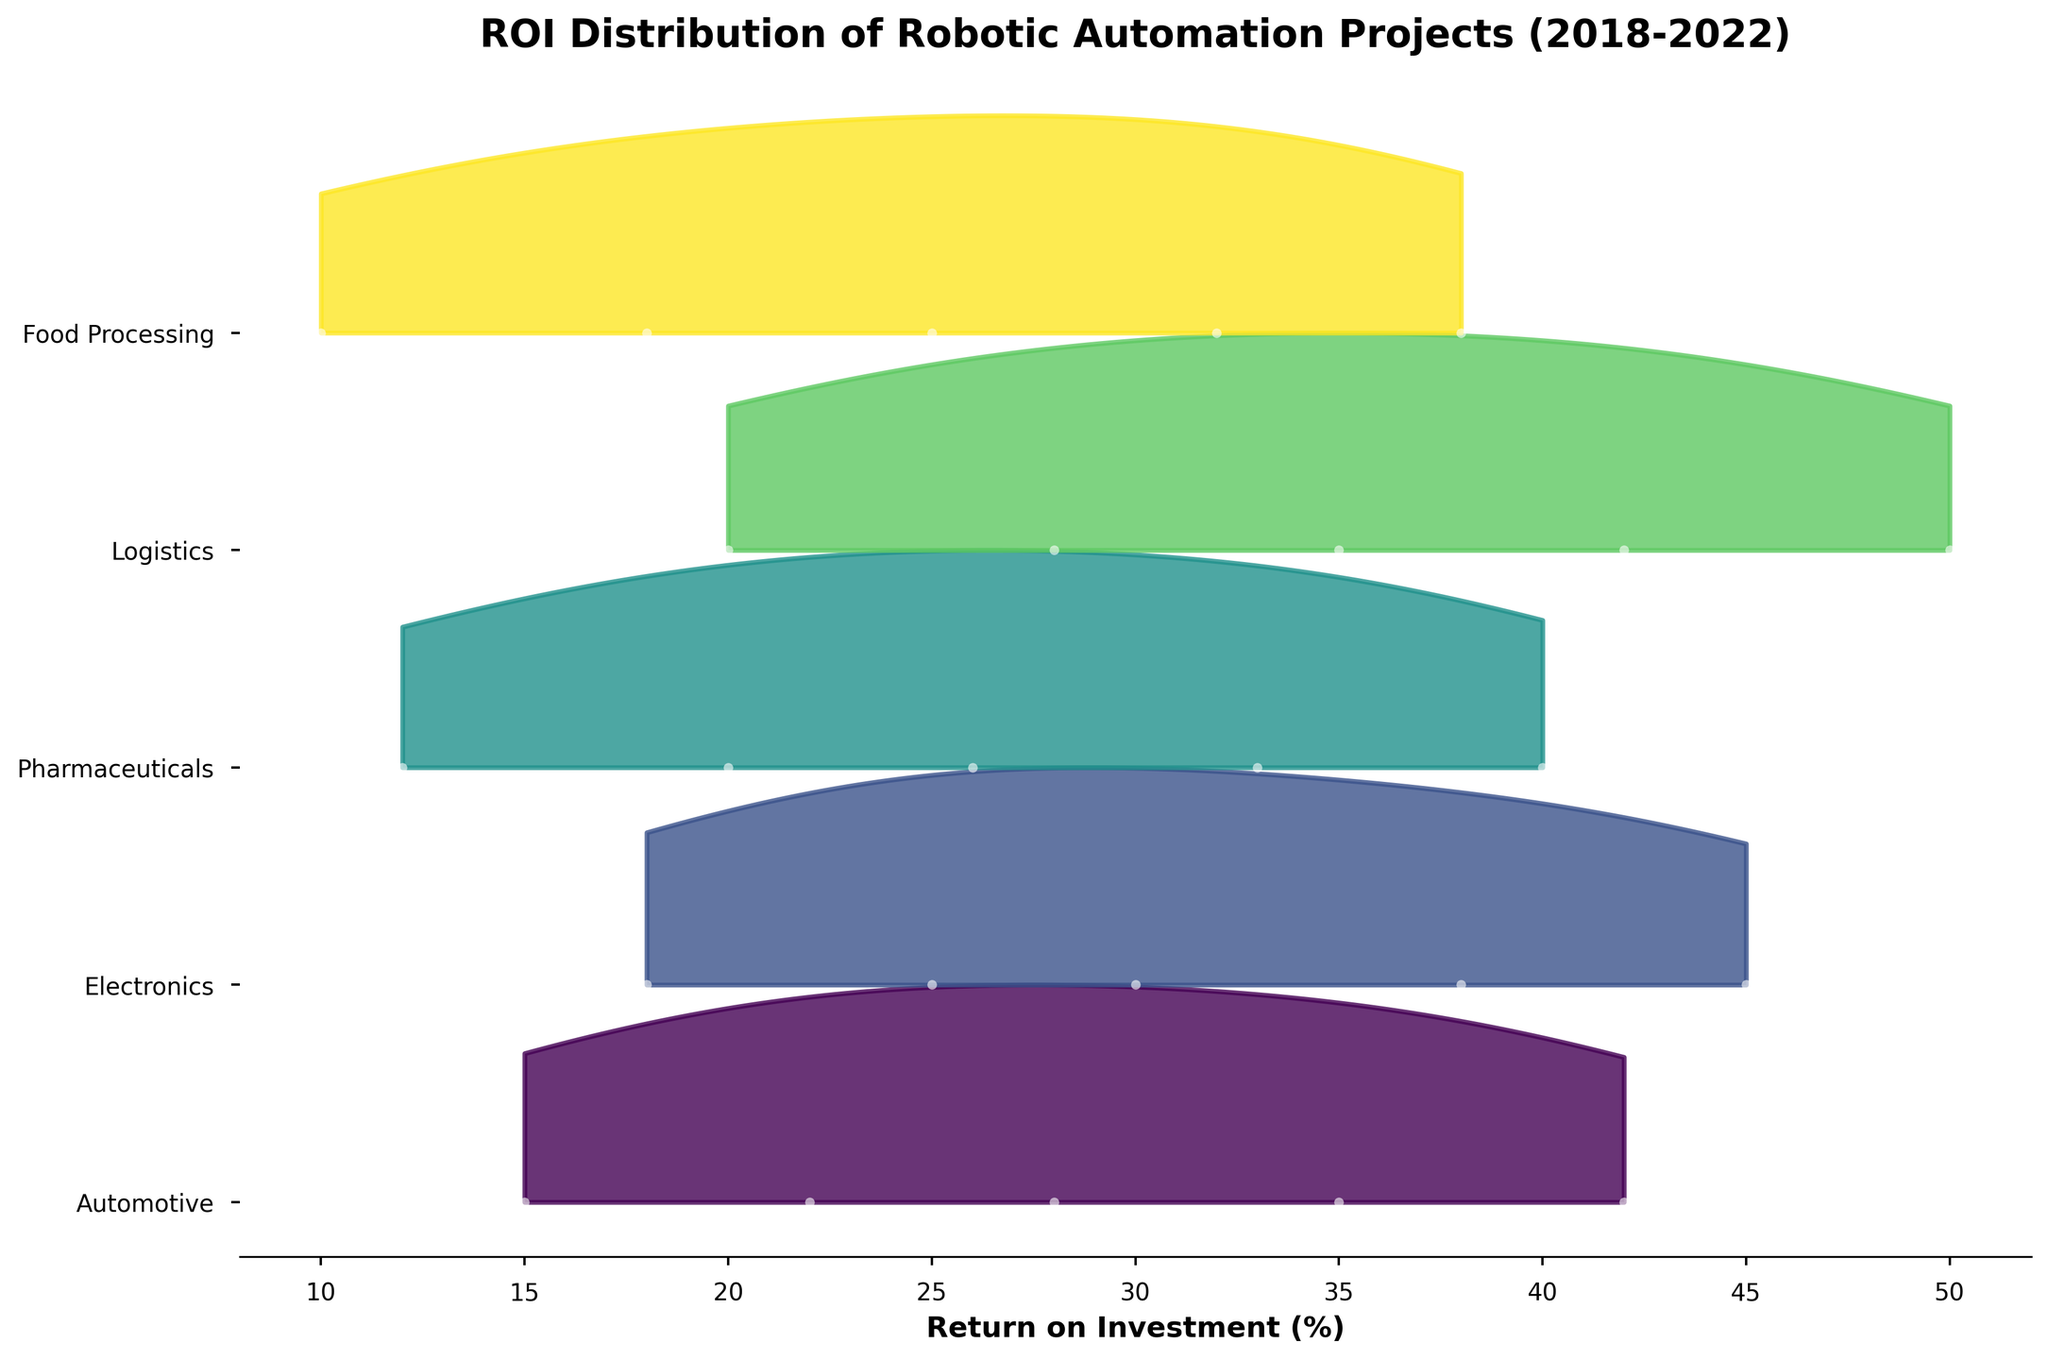What is the title of the figure? The title is located at the top of the figure and is formatted in bold. It provides a description of what the chart is depicting.
Answer: ROI Distribution of Robotic Automation Projects (2018-2022) Which industry has the highest ROI in the most recent year? Examine the data points plotted for the year 2022. Identify the highest value among these points.
Answer: Logistics How does the ROI distribution in the Electronics industry change over the years? Observe the shape and position of the ridgeline for the Electronics industry. Track how the ROI values increase each year by looking at the different years plotted.
Answer: Increasing trend What is the ROI range for Food Processing in 2021? Locate the data points and ridgeline for Food Processing in 2021. The range is determined by the minimum and maximum ROI values for that year.
Answer: 32% Which industry shows the most significant increase in ROI from 2018 to 2022? Compare the starting (2018) and ending (2022) points of each industry's ridgeline. The industry with the greatest difference demonstrates the most significant increase.
Answer: Logistics Are there any industries with overlapping ROI ranges in 2019? Compare the ROI ranges for each industry in 2019 by observing the plotted points and ridgelines. Determine if there are any intersections.
Answer: Yes, Automotive and Electronics overlap What can you infer about the stability of ROI for the Pharmaceuticals industry? Observe the uniformity and spread of the ridgeline for Pharmaceuticals. Consistent increases and narrow range suggest stability, while fluctuations and wide range suggest instability.
Answer: Relatively stable increase Which industry had the smallest increase in ROI from 2018 to 2022? Calculate the difference between the 2018 and 2022 ROI values for each industry and identify the smallest increase.
Answer: Food Processing What is the range of years plotted on the x-axis? Look at the labels on the x-axis to determine the range of years included in the data.
Answer: 2018-2022 Which industry's ROI fits most tightly around a central value in 2020? The tightness around a central value can be observed by the narrowness of the peak of the ridgeline in 2020 for the respective industries.
Answer: Pharmaceuticals 